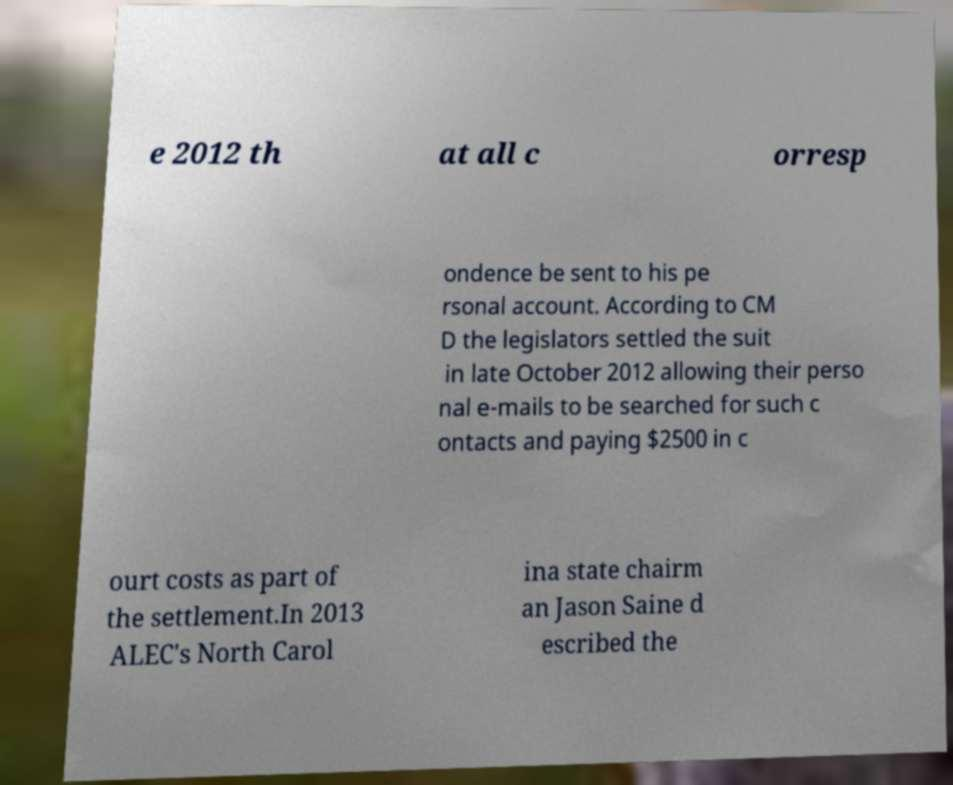There's text embedded in this image that I need extracted. Can you transcribe it verbatim? e 2012 th at all c orresp ondence be sent to his pe rsonal account. According to CM D the legislators settled the suit in late October 2012 allowing their perso nal e-mails to be searched for such c ontacts and paying $2500 in c ourt costs as part of the settlement.In 2013 ALEC's North Carol ina state chairm an Jason Saine d escribed the 